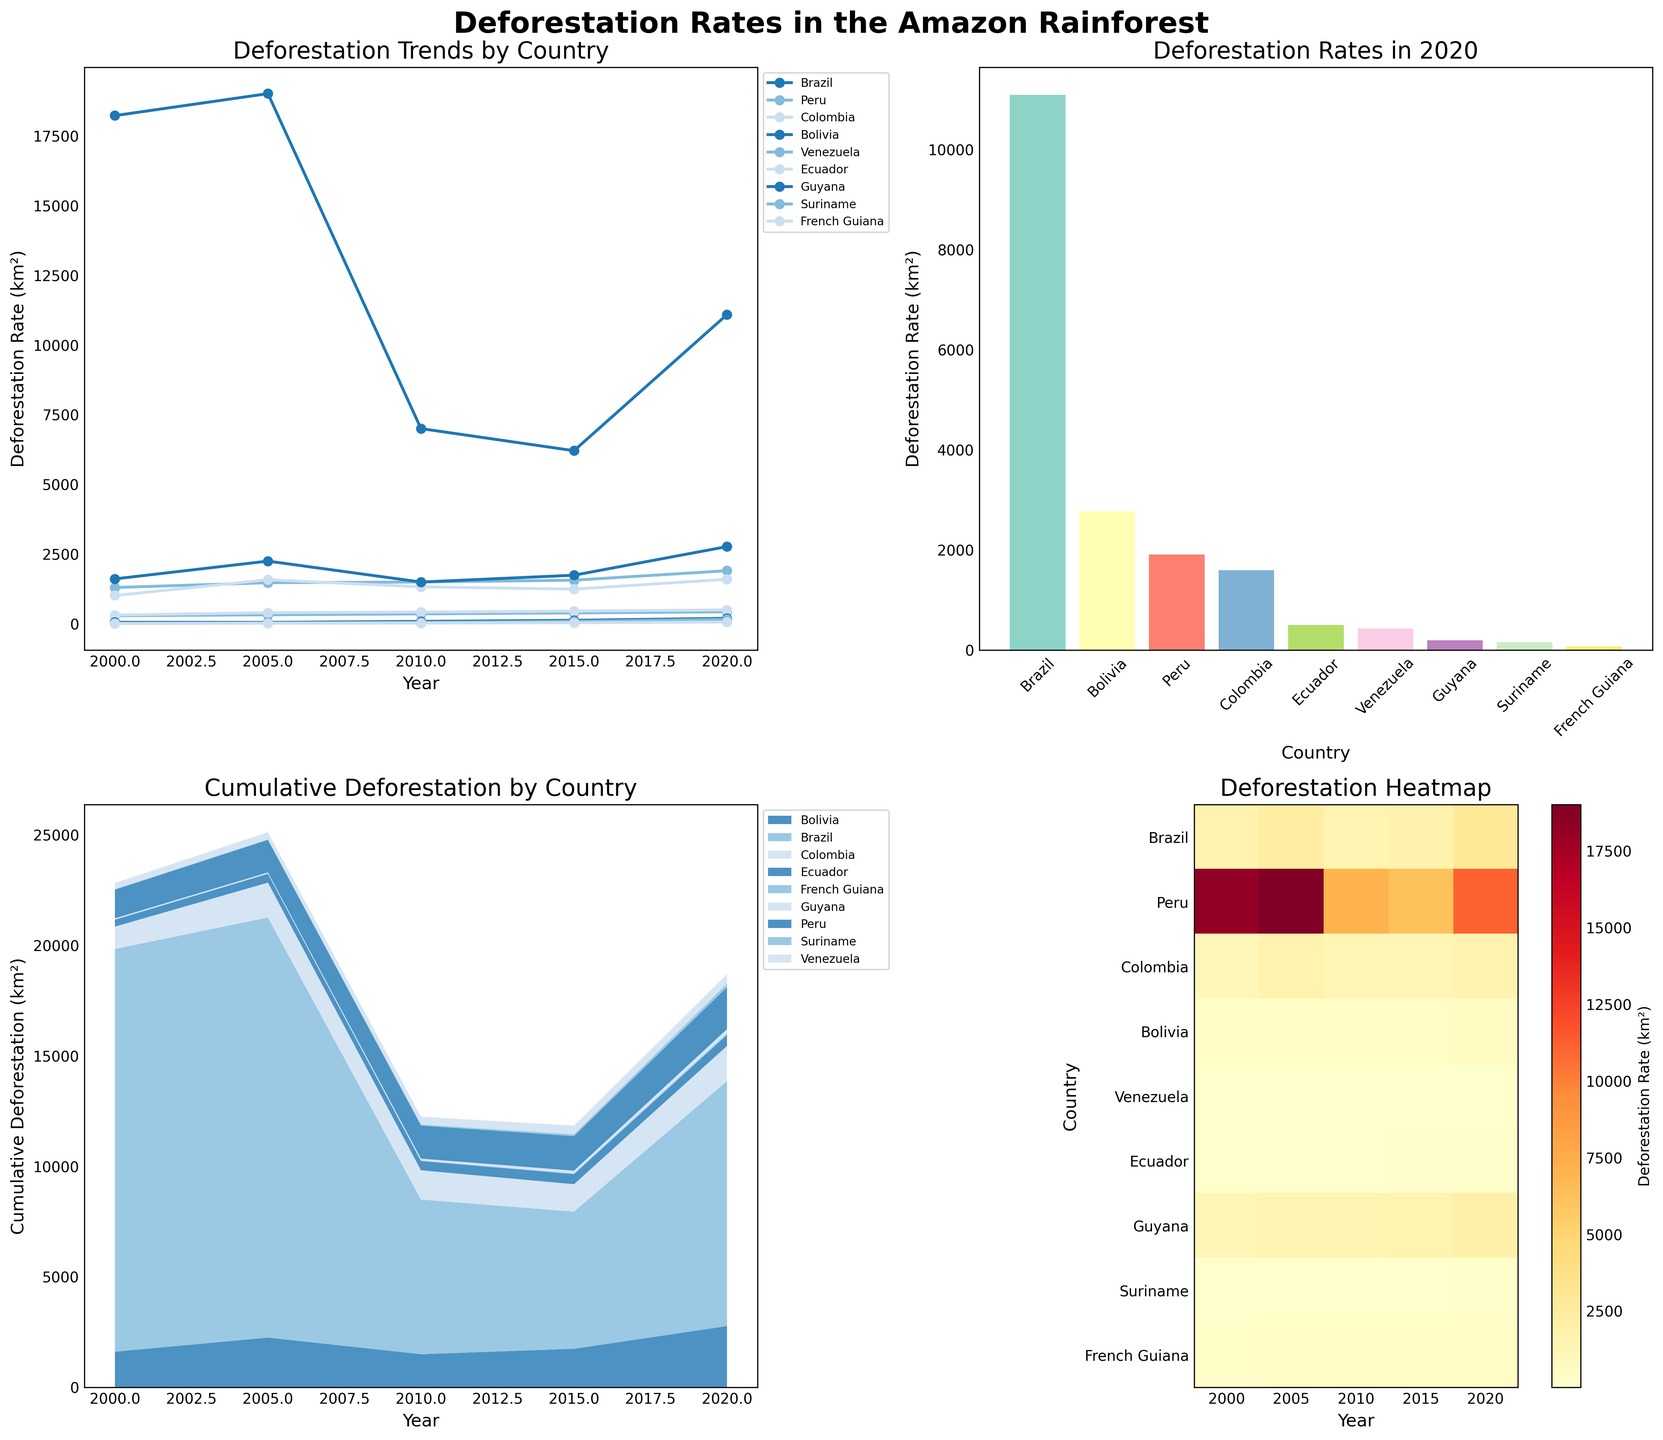What is the general trend of deforestation rates in Brazil from 2000 to 2020? In the line plot, observe the trend for Brazil. In 2000, the rate starts high at 18226, increases to 19014 in 2005, then significantly drops to 7000 in 2010, further declines to 6207 in 2015, and rises again to 11088 in 2020.
Answer: Fluctuating with a decreasing trend till 2015, then increasing Which country had the highest deforestation rate in 2020? Refer to the bar plot for 2020. The highest bar represents Brazil with a deforestation rate of 11088 km².
Answer: Brazil Compare the deforestation rates of Peru and Colombia in 2010. Check the line plot for 2010 values. Peru has a deforestation rate of 1496 km², while Colombia has 1324 km².
Answer: Peru has a higher rate than Colombia What is the average deforestation rate in Bolivia over the years shown? Use the line plot or data provided to sum Bolivia's rates (1609 + 2247 + 1496 + 1741 + 2768 = 9861) and divide by the number of years (5).
Answer: 1972.2 km² How does the cumulative deforestation for Ecuador change from 2000 to 2020? In the stacked area plot, observe the section for Ecuador, which increases steadily from the bottom. This indicates a consistent rise in cumulative deforestation from 2000 to 2020.
Answer: Steadily increases Which country experienced the least deforestation in 2000? On the heatmap, locate the color legend and find the least intense (lightest) color for the year 2000. Suriname shows the lowest value of 13 km².
Answer: Suriname What is the difference in deforestation rates between Bolivia and Venezuela in 2020? From the bar plot, Bolivia has 2768 km² and Venezuela has 428 km² in 2020. The difference is 2768 - 428.
Answer: 2340 km² Identify two countries with the closest deforestation rates in 2015. Examine the bar lengths in the heatmap for 2015. Bolivia and Colombia have similar nearby values, being 1741 km² and 1242 km² respectively.
Answer: Bolivia and Colombia Which country shows a consistent increase in deforestation rates from 2000 to 2020? Look in the line plot for any country line continuously rising. Venezuela steadily increases from 287 km² in 2000 to 428 km² in 2020.
Answer: Venezuela What was the cumulative deforestation in the entire Amazon rainforest in 2020? Add up the deforestation rates for all countries in the bar plot for 2020. The total is: 11088 + 1903 + 1594 + 2768 + 428 + 498 + 195 + 157 + 63
Answer: 17894 km² 